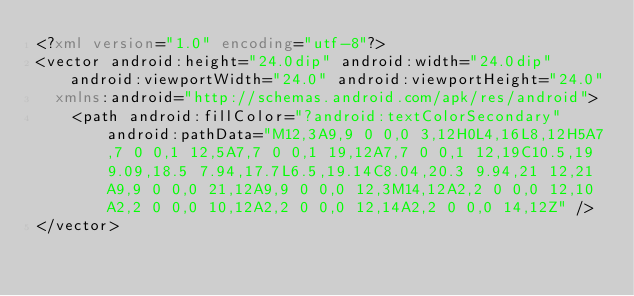<code> <loc_0><loc_0><loc_500><loc_500><_XML_><?xml version="1.0" encoding="utf-8"?>
<vector android:height="24.0dip" android:width="24.0dip" android:viewportWidth="24.0" android:viewportHeight="24.0"
  xmlns:android="http://schemas.android.com/apk/res/android">
    <path android:fillColor="?android:textColorSecondary" android:pathData="M12,3A9,9 0 0,0 3,12H0L4,16L8,12H5A7,7 0 0,1 12,5A7,7 0 0,1 19,12A7,7 0 0,1 12,19C10.5,19 9.09,18.5 7.94,17.7L6.5,19.14C8.04,20.3 9.94,21 12,21A9,9 0 0,0 21,12A9,9 0 0,0 12,3M14,12A2,2 0 0,0 12,10A2,2 0 0,0 10,12A2,2 0 0,0 12,14A2,2 0 0,0 14,12Z" />
</vector></code> 